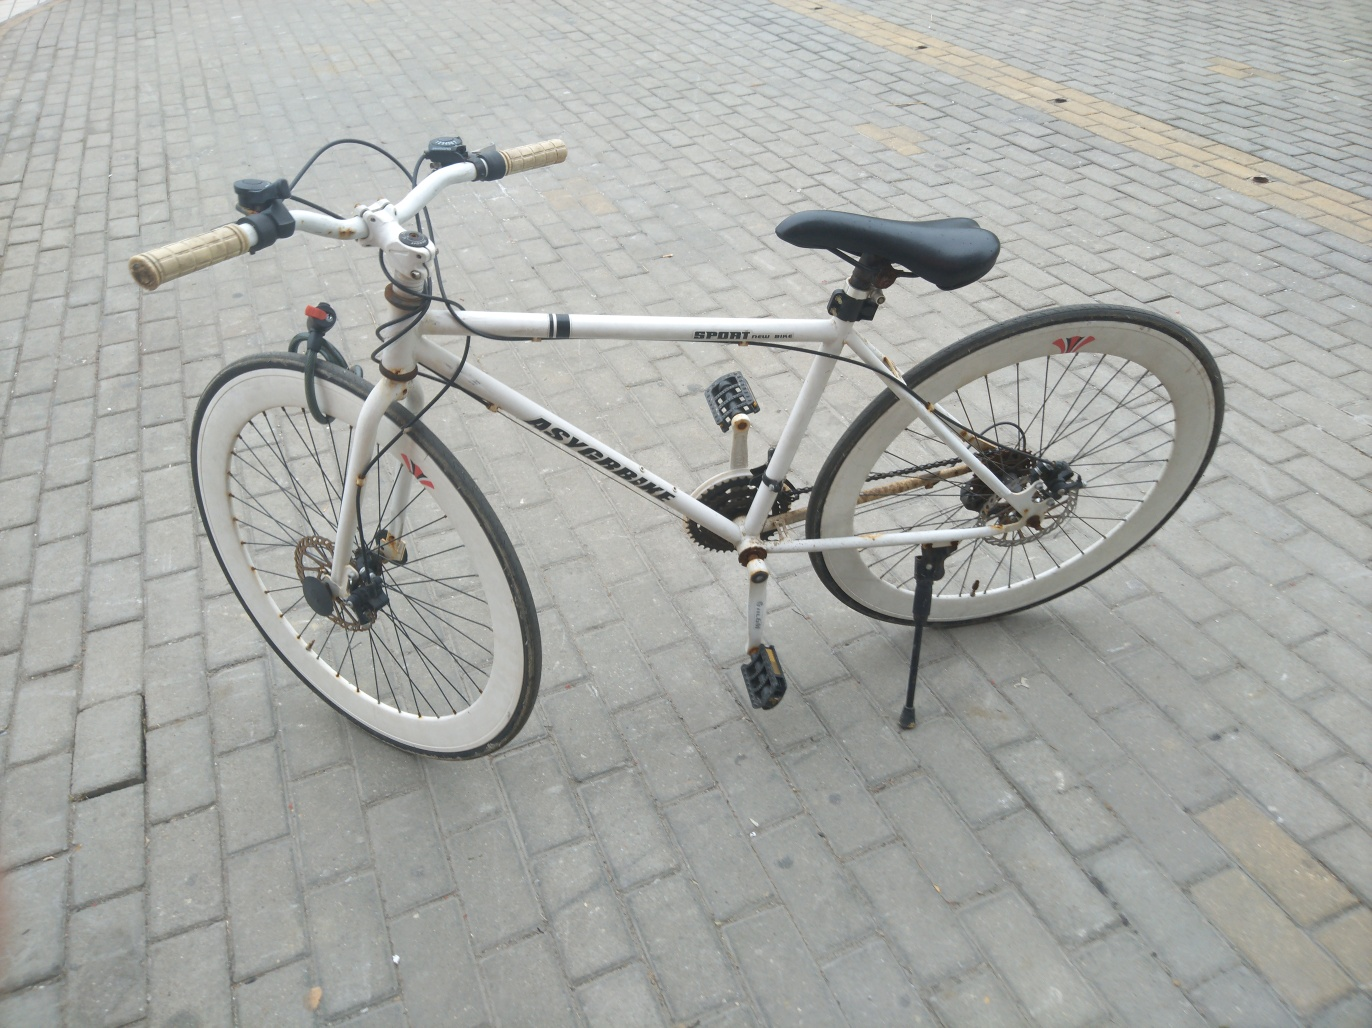Can you describe the type and condition of the bicycle? This appears to be a sporty, white road bicycle suitable for both recreational riding and commuting. The condition seems to be moderately used with some visible dirt and wear on the tires and frame, indicating it has been actively ridden. It is equipped with a kickstand, reflecting the owner's preference for utility and convenience. 